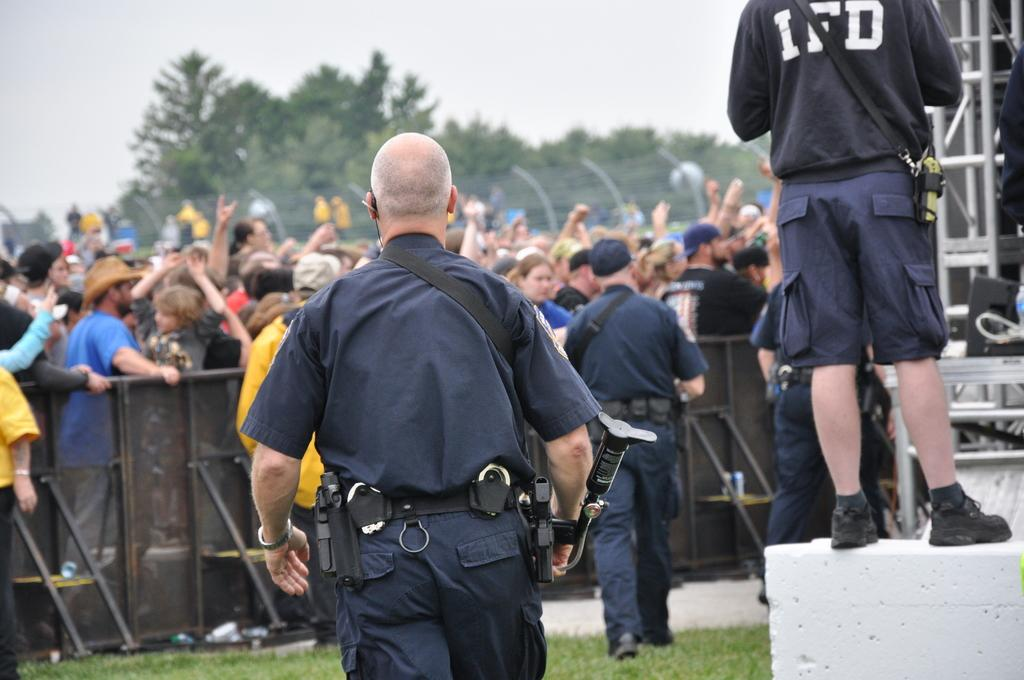What is the main subject of the image? The main subject of the image is a crowd standing on the ground. What can be seen in the background of the image? The sky, trees, street lights, an iron grill, and grass are visible in the background. What advice is the crowd giving to the person in the picture? There is no person in the picture, and the crowd is not giving any advice. 